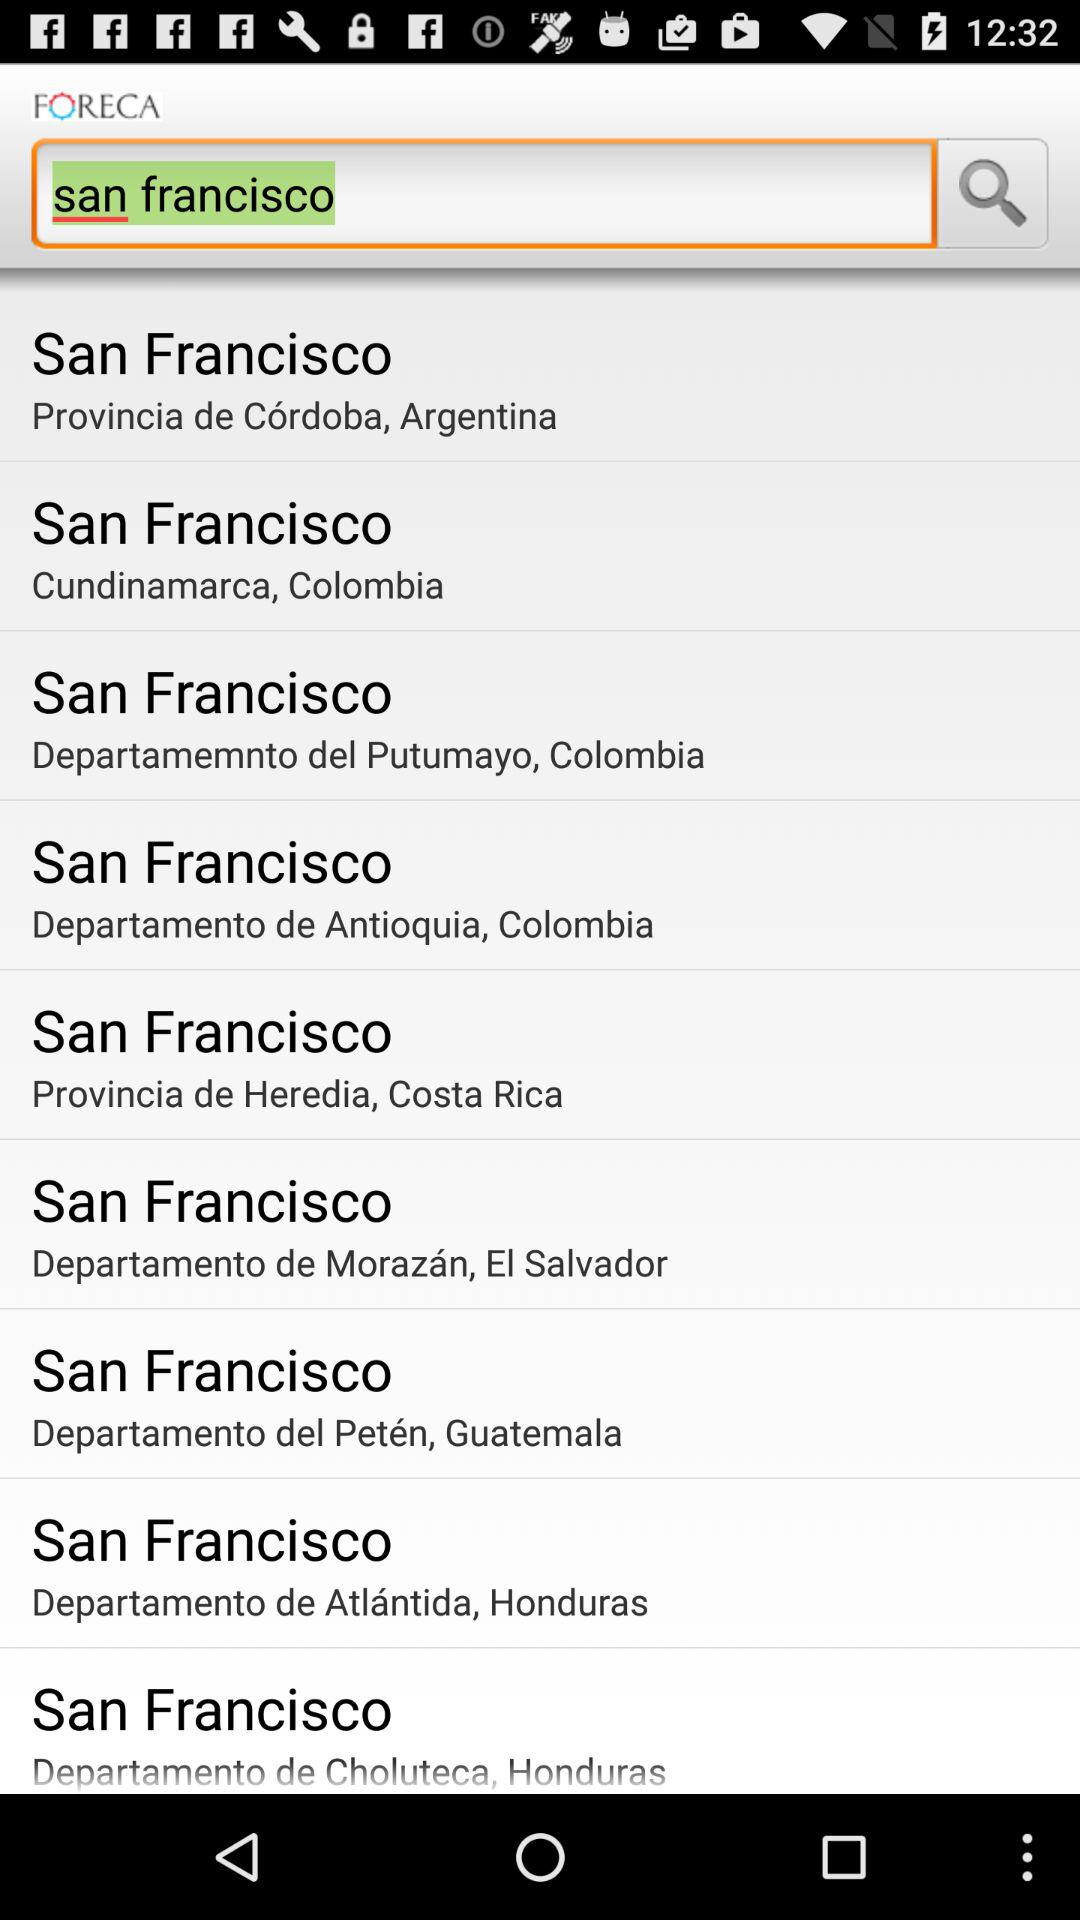What location is searched? The searched location is San Francisco. 